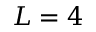Convert formula to latex. <formula><loc_0><loc_0><loc_500><loc_500>L = 4</formula> 